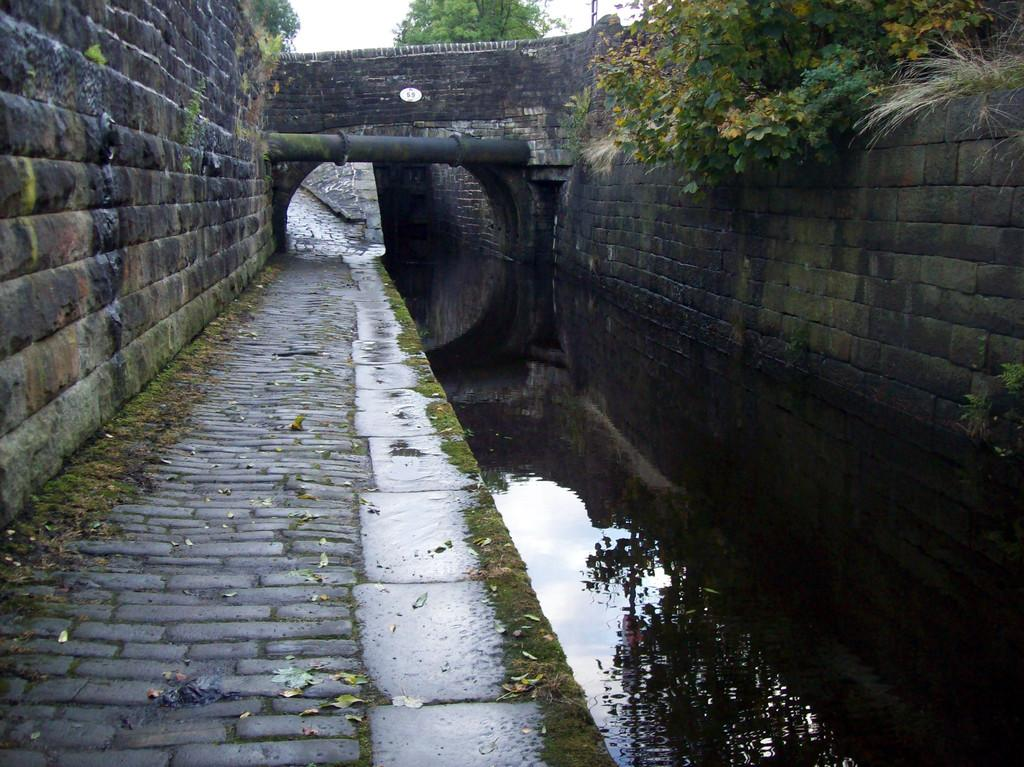What is located on the left side of the image? There is a wall on the left side of the image. What is located on the right side of the image? There is a wall on the right side of the image. What is in the middle of the image? There is water in the middle of the image. What can be seen in the background of the image? There is a tunnel, a pipe, trees, a pole, and the sky visible in the background of the image. What type of flower is being used as a centerpiece during the feast in the image? There is no feast or flower present in the image. What appliance is being used to clean the water in the middle of the image? There is no appliance or cleaning activity depicted in the image; it simply shows water in the middle. 